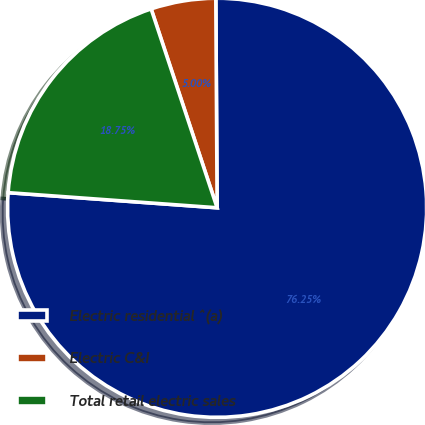<chart> <loc_0><loc_0><loc_500><loc_500><pie_chart><fcel>Electric residential ^(a)<fcel>Electric C&I<fcel>Total retail electric sales<nl><fcel>76.25%<fcel>5.0%<fcel>18.75%<nl></chart> 